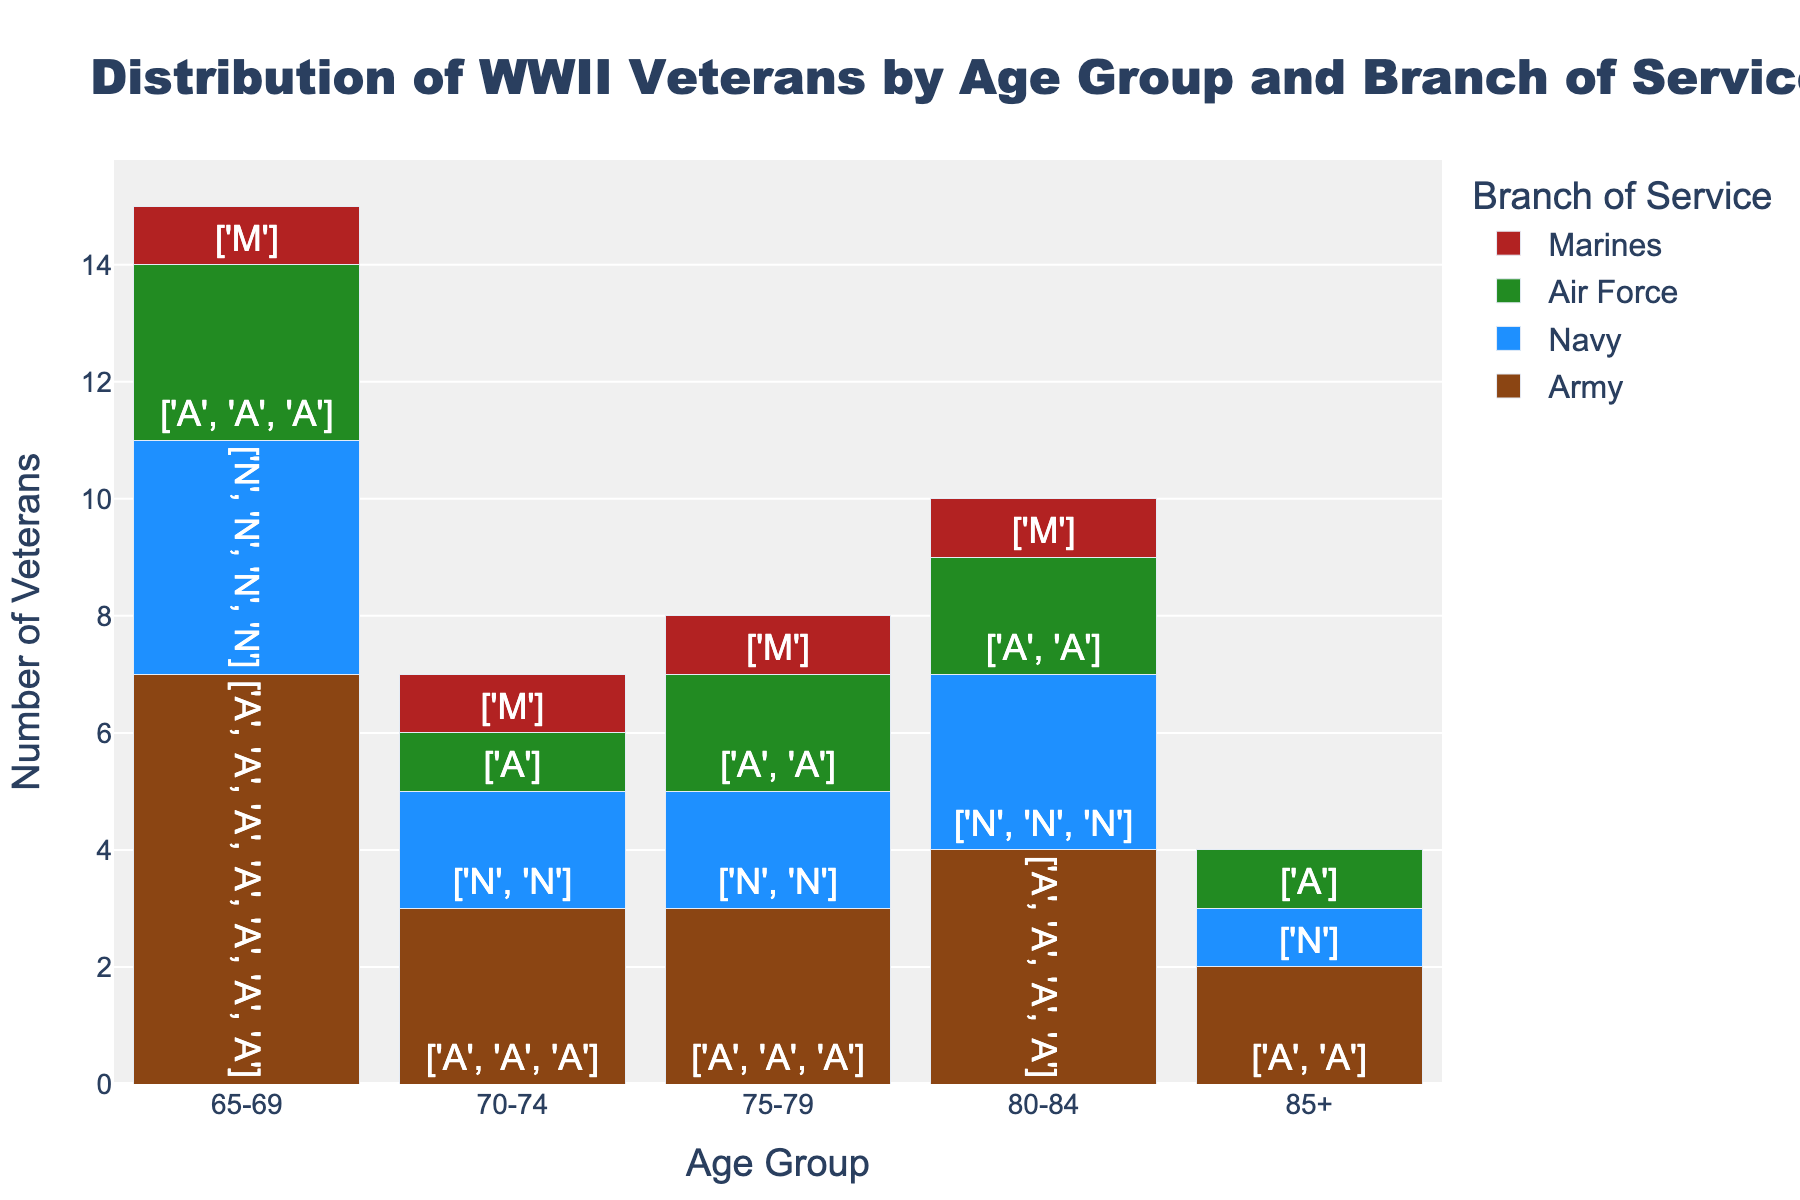What's the title of the figure? The title of the figure is usually displayed at the top of the chart, centered and in larger font. In this case, it states the content and focus of the chart.
Answer: Distribution of WWII Veterans by Age Group and Branch of Service What color represents the Army in the figure? Each branch is represented by a different color bar in the stacked bar chart. The colors for each branch were defined in the provided code. The Army is represented by a brownish color.
Answer: Brown Which age group has the highest number of Navy veterans? By looking at the Navy section (blue colored bars) of each age group, we can compare the heights of the bars. The tallest Navy bar indicates the age group with the highest number of veterans.
Answer: 75-79 How many Marines are in the 70-74 age group? The emojis within each bar represent the number of veterans. Count the figures in the Marine section for the 70-74 age group.
Answer: 2 Which branch has the smallest number of veterans in the 85+ age group? Compare the heights of the bars within the 85+ age category and identify the smallest one.
Answer: Marines What is the total number of veterans in the 65-69 age group? Add up the number of veterans from all branches in the 65-69 age group. Count and sum up all the emoji figures in this age group.
Answer: 14 How does the number of Air Force veterans in the 75-79 age group compare to those in the 80-84 age group? Examine the bars for the Air Force (green colored bars) in both age groups. Compare the heights to see which group has more veterans.
Answer: 75-79 has more Which age group has the most balanced distribution of veterans across all branches? Look for an age group where the heights of the bars for each branch are relatively similar, meaning each branch has a comparable number of veterans.
Answer: 75-79 Are there more Army veterans in the 80-84 age group or Marines veterans in the 75-79 age group? Compare the number of Army veterans in the 80-84 age group (brown bar) to the number of Marines veterans in the 75-79 age group (red bar).
Answer: Army in 80-84 Which age group has the highest total number of veterans? Sum the number of veterans in each branch for all age groups and compare the totals to find the highest one.
Answer: 75-79 